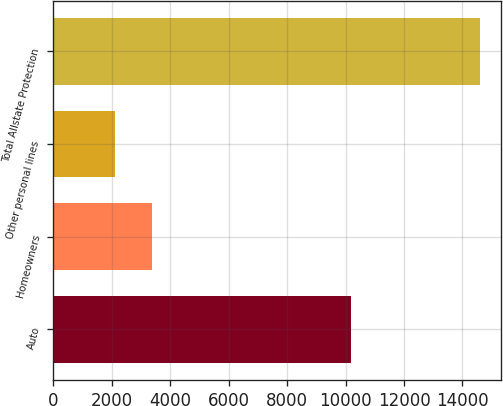Convert chart to OTSL. <chart><loc_0><loc_0><loc_500><loc_500><bar_chart><fcel>Auto<fcel>Homeowners<fcel>Other personal lines<fcel>Total Allstate Protection<nl><fcel>10175<fcel>3376.4<fcel>2131<fcel>14585<nl></chart> 